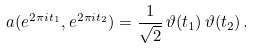<formula> <loc_0><loc_0><loc_500><loc_500>a ( e ^ { 2 \pi i t _ { 1 } } , e ^ { 2 \pi i t _ { 2 } } ) = \frac { 1 } { \sqrt { 2 } } \, \vartheta ( t _ { 1 } ) \, \vartheta ( t _ { 2 } ) \, .</formula> 